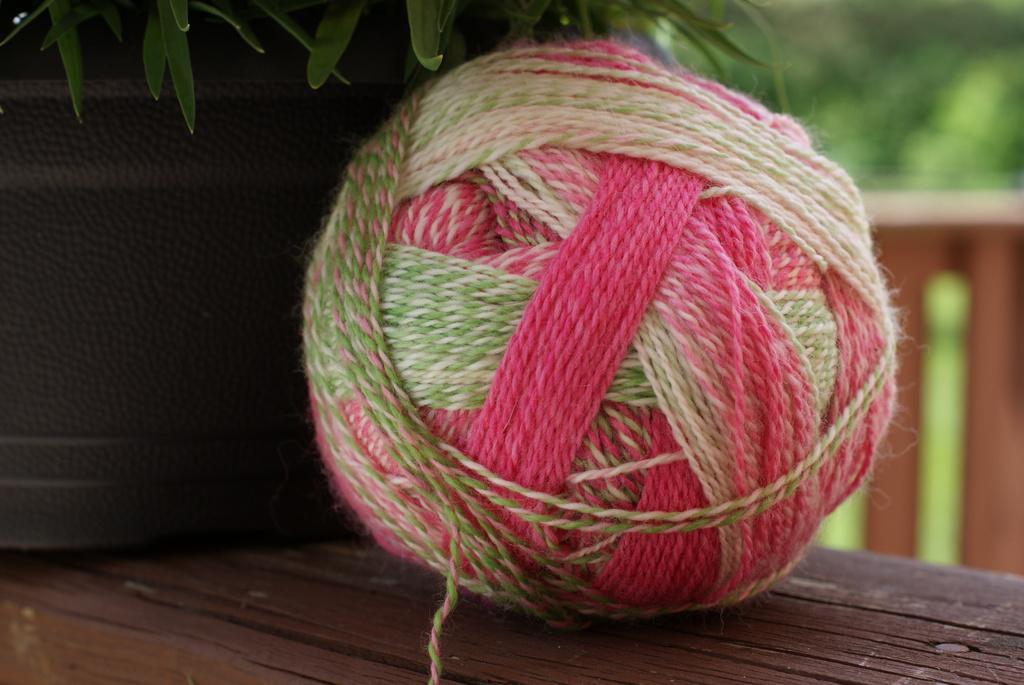In one or two sentences, can you explain what this image depicts? In the image there is a woolen thread ball on the wooden table beside a plant, behind it seems to be a fence in front of the garden. 